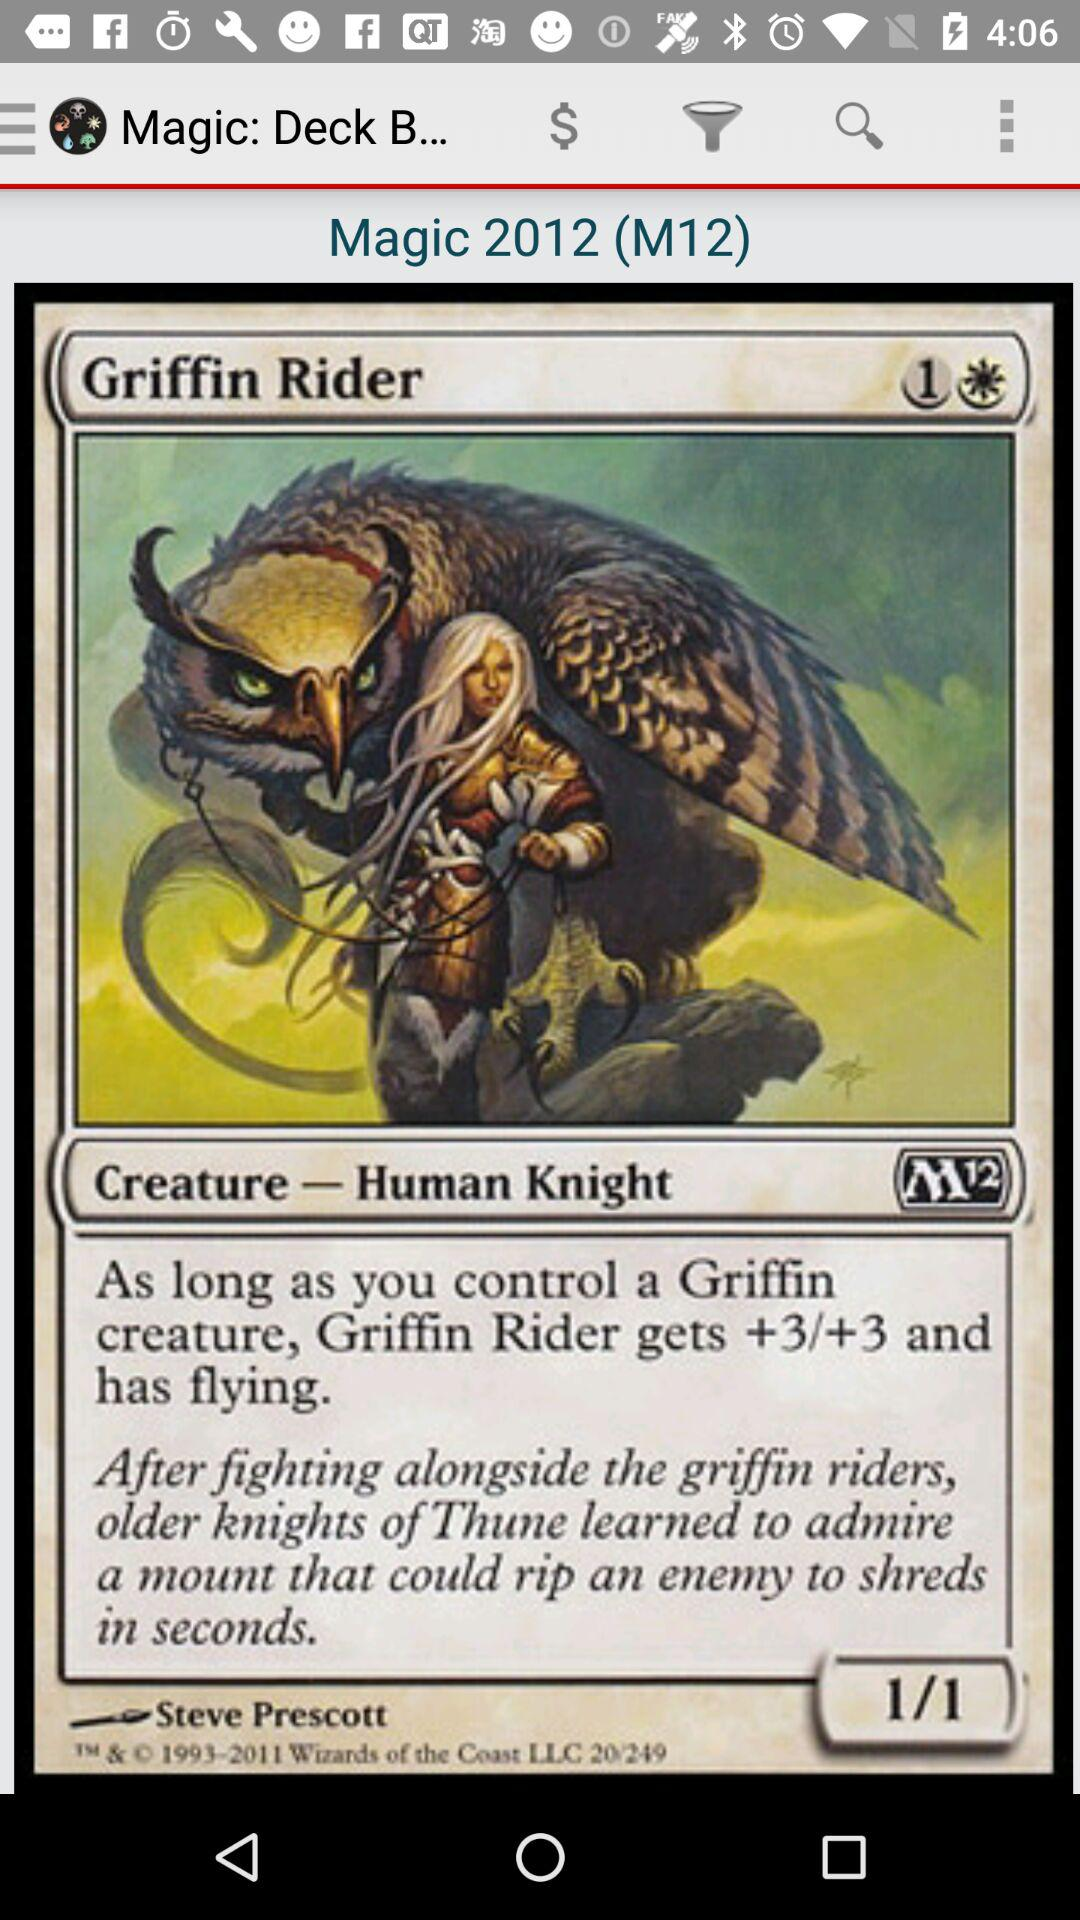What is the name of the magic card that has the text 'After fighting alongside the griffin riders, older knights of Thune learned to admire a mount that could rip an enemy to shreds in seconds.'?
Answer the question using a single word or phrase. Griffin Rider 